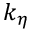Convert formula to latex. <formula><loc_0><loc_0><loc_500><loc_500>k _ { \eta }</formula> 